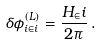<formula> <loc_0><loc_0><loc_500><loc_500>\delta \phi ^ { ( L ) } _ { i \in i } = \frac { H _ { \in } i } { 2 \pi } \, .</formula> 